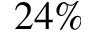<formula> <loc_0><loc_0><loc_500><loc_500>2 4 \%</formula> 